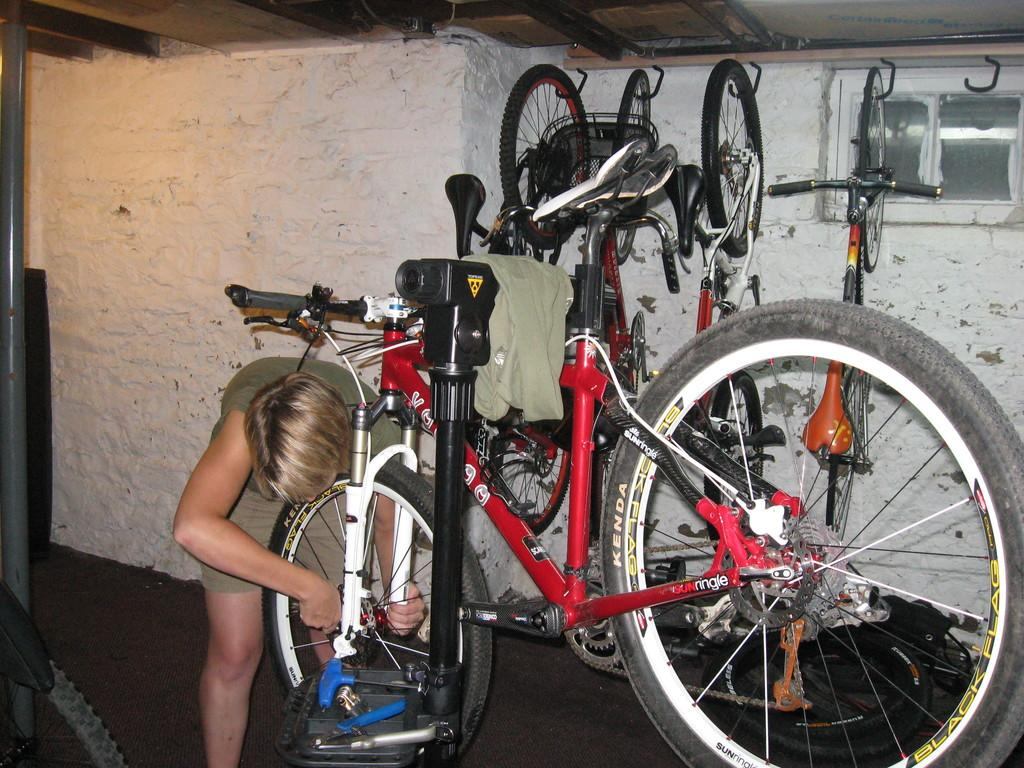Who is present in the image? There is a woman in the image. What is the woman wearing? The woman is wearing a dress. What can be seen in the middle of the image? There are cycles in the middle of the image. What architectural features are visible in the background of the image? There is a wall, a window, and a roof in the background of the image. How many arms does the jellyfish have in the image? There is no jellyfish present in the image; it only features a woman, cycles, and architectural features in the background. 